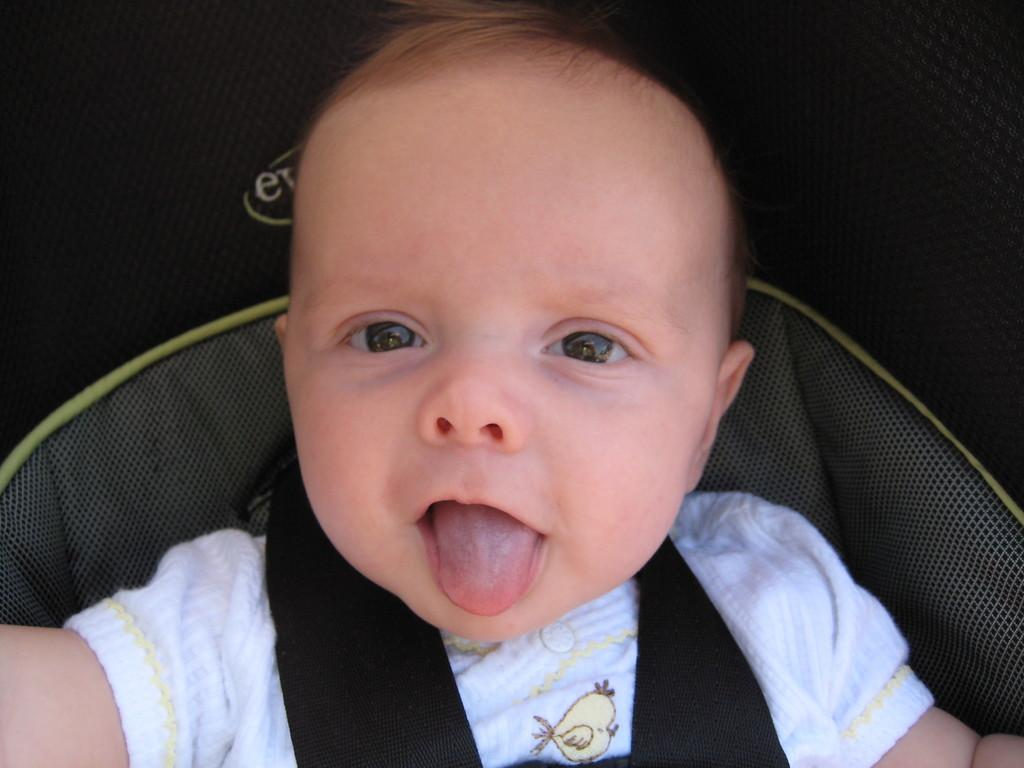What is the main subject of the image? The main subject of the image is a kid. What is the kid wearing in the image? The kid is wearing a white T-shirt in the image. What is the kid's position or mode of transportation in the image? The kid appears to be sitting in a trolley in the image. What type of key is the kid holding in the image? There is no key present in the image; the kid is sitting in a trolley and wearing a white T-shirt. 